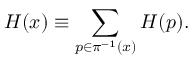Convert formula to latex. <formula><loc_0><loc_0><loc_500><loc_500>H ( x ) \equiv \sum _ { p \in \pi ^ { - 1 } ( x ) } H ( p ) .</formula> 